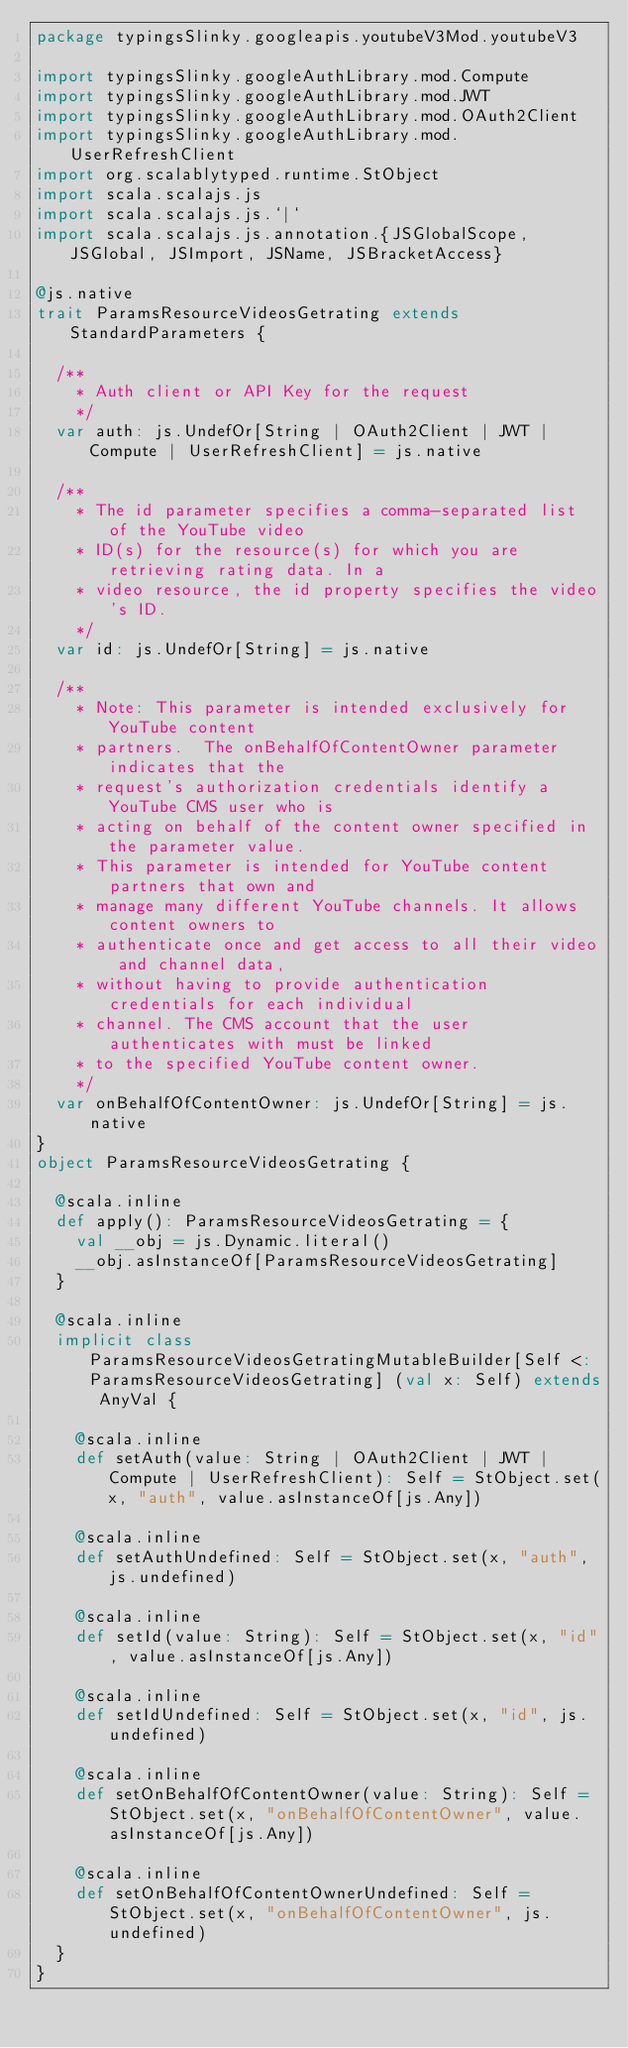Convert code to text. <code><loc_0><loc_0><loc_500><loc_500><_Scala_>package typingsSlinky.googleapis.youtubeV3Mod.youtubeV3

import typingsSlinky.googleAuthLibrary.mod.Compute
import typingsSlinky.googleAuthLibrary.mod.JWT
import typingsSlinky.googleAuthLibrary.mod.OAuth2Client
import typingsSlinky.googleAuthLibrary.mod.UserRefreshClient
import org.scalablytyped.runtime.StObject
import scala.scalajs.js
import scala.scalajs.js.`|`
import scala.scalajs.js.annotation.{JSGlobalScope, JSGlobal, JSImport, JSName, JSBracketAccess}

@js.native
trait ParamsResourceVideosGetrating extends StandardParameters {
  
  /**
    * Auth client or API Key for the request
    */
  var auth: js.UndefOr[String | OAuth2Client | JWT | Compute | UserRefreshClient] = js.native
  
  /**
    * The id parameter specifies a comma-separated list of the YouTube video
    * ID(s) for the resource(s) for which you are retrieving rating data. In a
    * video resource, the id property specifies the video's ID.
    */
  var id: js.UndefOr[String] = js.native
  
  /**
    * Note: This parameter is intended exclusively for YouTube content
    * partners.  The onBehalfOfContentOwner parameter indicates that the
    * request's authorization credentials identify a YouTube CMS user who is
    * acting on behalf of the content owner specified in the parameter value.
    * This parameter is intended for YouTube content partners that own and
    * manage many different YouTube channels. It allows content owners to
    * authenticate once and get access to all their video and channel data,
    * without having to provide authentication credentials for each individual
    * channel. The CMS account that the user authenticates with must be linked
    * to the specified YouTube content owner.
    */
  var onBehalfOfContentOwner: js.UndefOr[String] = js.native
}
object ParamsResourceVideosGetrating {
  
  @scala.inline
  def apply(): ParamsResourceVideosGetrating = {
    val __obj = js.Dynamic.literal()
    __obj.asInstanceOf[ParamsResourceVideosGetrating]
  }
  
  @scala.inline
  implicit class ParamsResourceVideosGetratingMutableBuilder[Self <: ParamsResourceVideosGetrating] (val x: Self) extends AnyVal {
    
    @scala.inline
    def setAuth(value: String | OAuth2Client | JWT | Compute | UserRefreshClient): Self = StObject.set(x, "auth", value.asInstanceOf[js.Any])
    
    @scala.inline
    def setAuthUndefined: Self = StObject.set(x, "auth", js.undefined)
    
    @scala.inline
    def setId(value: String): Self = StObject.set(x, "id", value.asInstanceOf[js.Any])
    
    @scala.inline
    def setIdUndefined: Self = StObject.set(x, "id", js.undefined)
    
    @scala.inline
    def setOnBehalfOfContentOwner(value: String): Self = StObject.set(x, "onBehalfOfContentOwner", value.asInstanceOf[js.Any])
    
    @scala.inline
    def setOnBehalfOfContentOwnerUndefined: Self = StObject.set(x, "onBehalfOfContentOwner", js.undefined)
  }
}
</code> 